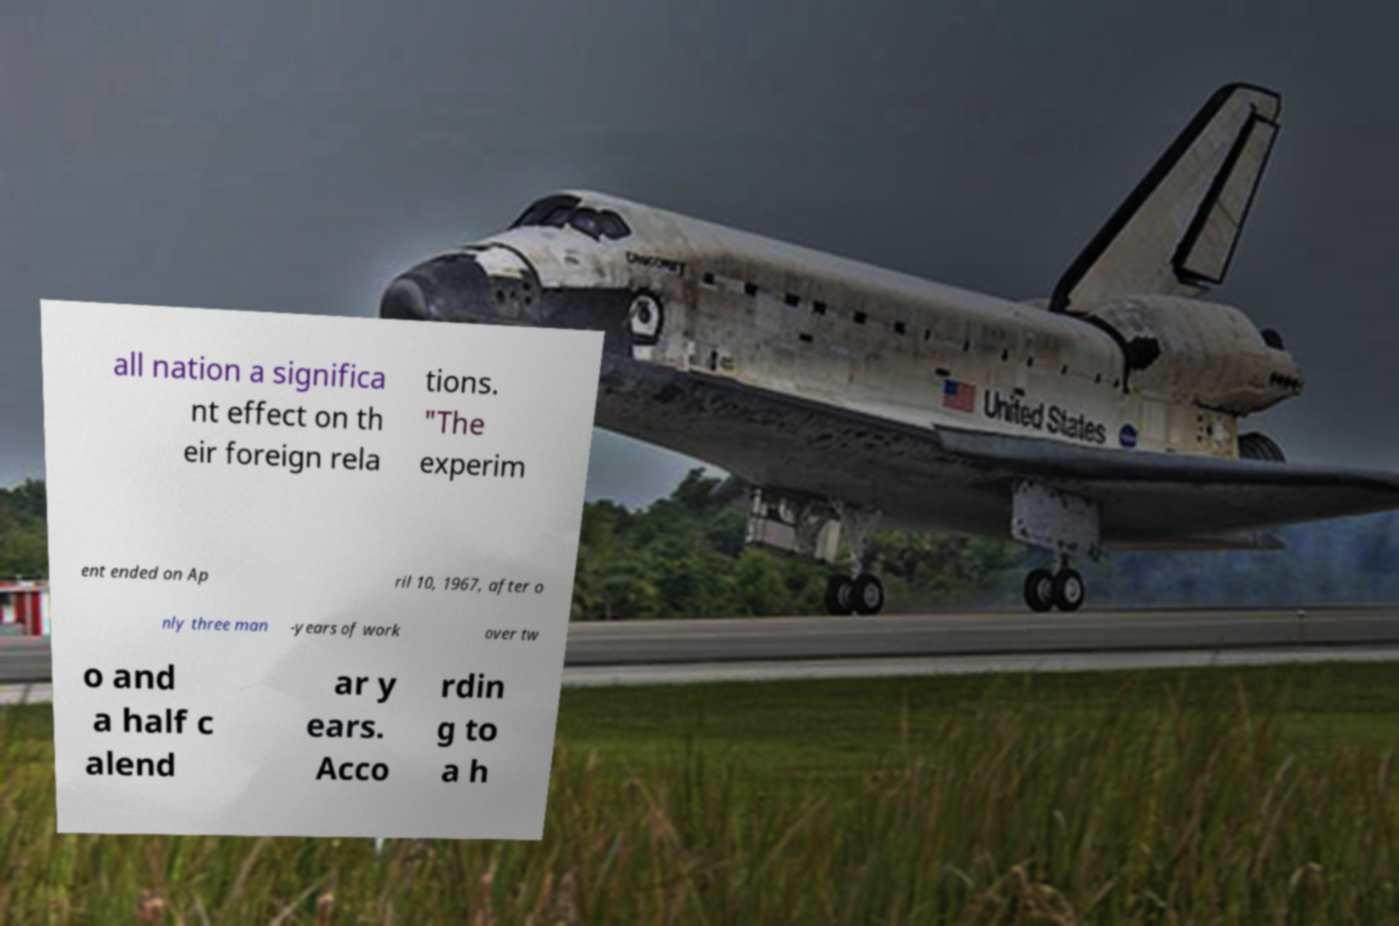Can you read and provide the text displayed in the image?This photo seems to have some interesting text. Can you extract and type it out for me? all nation a significa nt effect on th eir foreign rela tions. "The experim ent ended on Ap ril 10, 1967, after o nly three man -years of work over tw o and a half c alend ar y ears. Acco rdin g to a h 